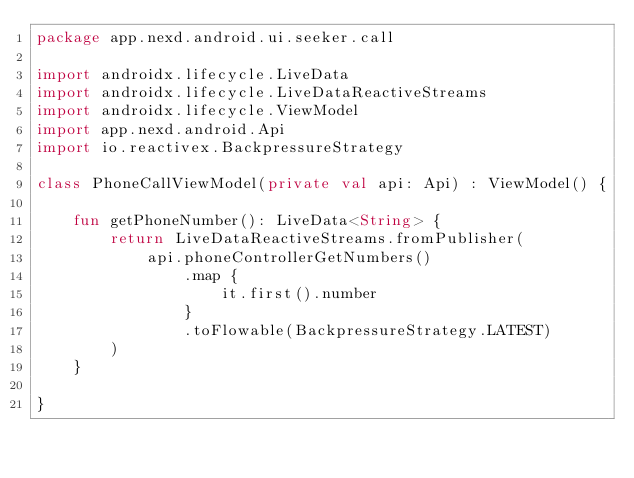<code> <loc_0><loc_0><loc_500><loc_500><_Kotlin_>package app.nexd.android.ui.seeker.call

import androidx.lifecycle.LiveData
import androidx.lifecycle.LiveDataReactiveStreams
import androidx.lifecycle.ViewModel
import app.nexd.android.Api
import io.reactivex.BackpressureStrategy

class PhoneCallViewModel(private val api: Api) : ViewModel() {

    fun getPhoneNumber(): LiveData<String> {
        return LiveDataReactiveStreams.fromPublisher(
            api.phoneControllerGetNumbers()
                .map {
                    it.first().number
                }
                .toFlowable(BackpressureStrategy.LATEST)
        )
    }

}</code> 